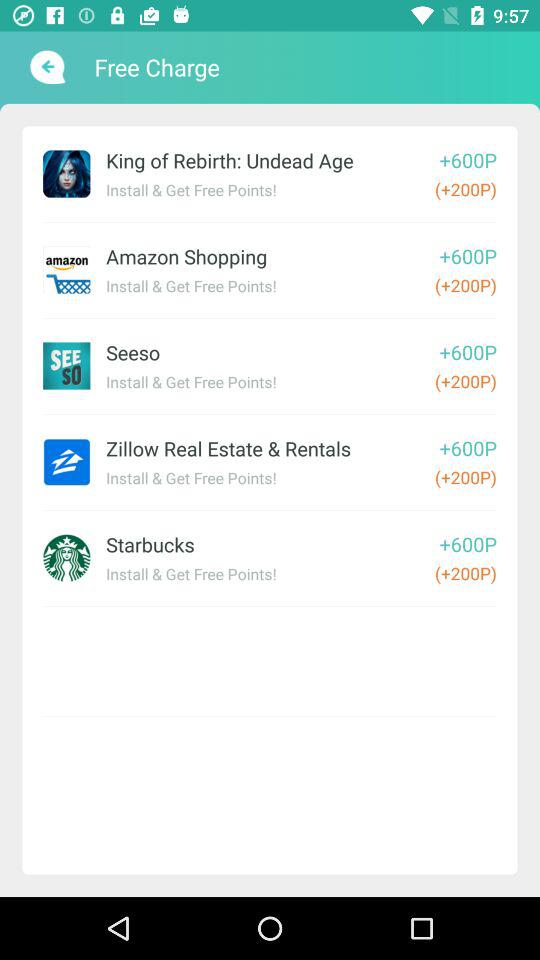How many points can be earned by installing "Amazon Shopping"? By installing "Amazon Shopping", 200 points can be earned. 